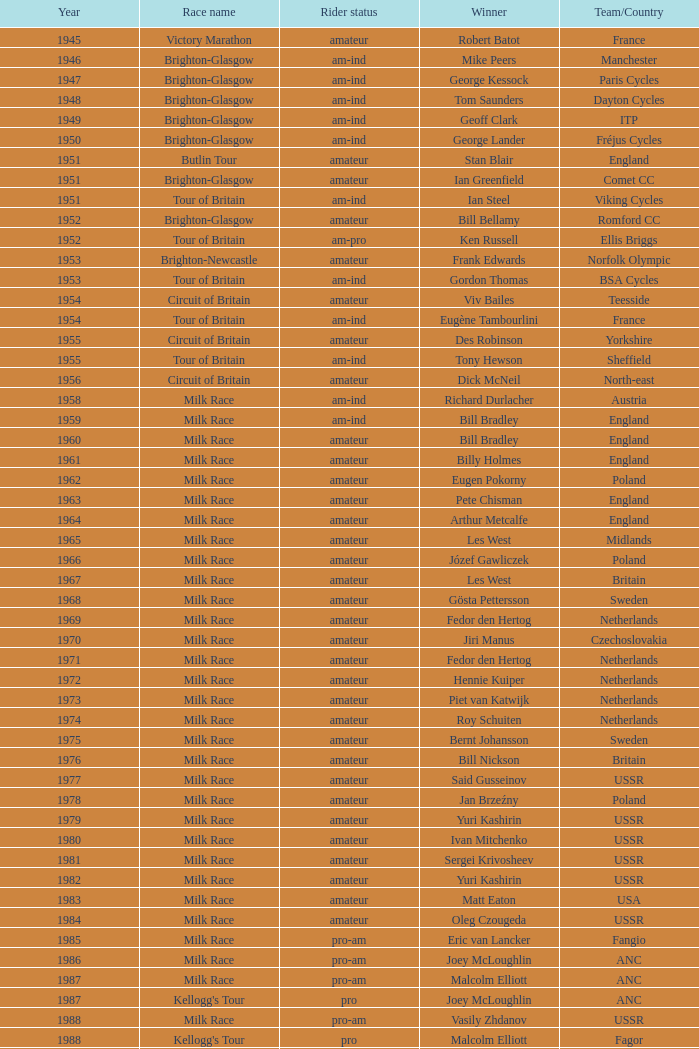What year marks phil anderson's most recent triumph? 1993.0. 